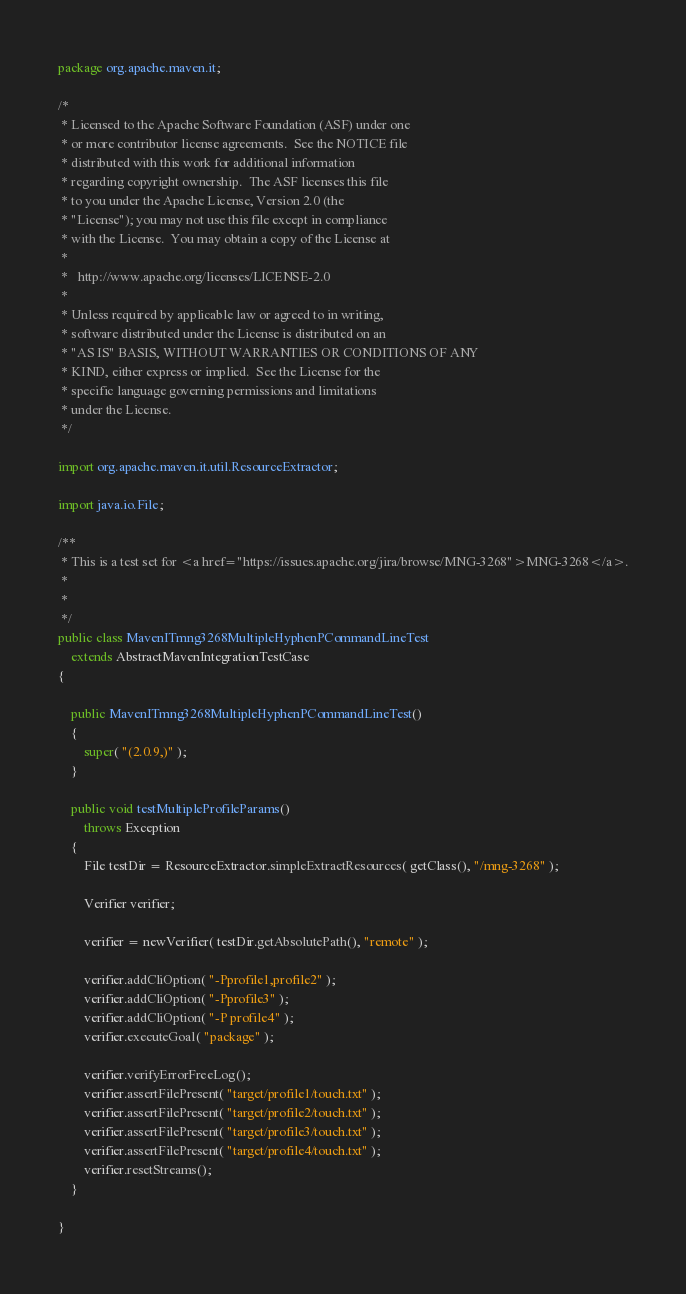<code> <loc_0><loc_0><loc_500><loc_500><_Java_>package org.apache.maven.it;

/*
 * Licensed to the Apache Software Foundation (ASF) under one
 * or more contributor license agreements.  See the NOTICE file
 * distributed with this work for additional information
 * regarding copyright ownership.  The ASF licenses this file
 * to you under the Apache License, Version 2.0 (the
 * "License"); you may not use this file except in compliance
 * with the License.  You may obtain a copy of the License at
 *
 *   http://www.apache.org/licenses/LICENSE-2.0
 *
 * Unless required by applicable law or agreed to in writing,
 * software distributed under the License is distributed on an
 * "AS IS" BASIS, WITHOUT WARRANTIES OR CONDITIONS OF ANY
 * KIND, either express or implied.  See the License for the
 * specific language governing permissions and limitations
 * under the License.
 */

import org.apache.maven.it.util.ResourceExtractor;

import java.io.File;

/**
 * This is a test set for <a href="https://issues.apache.org/jira/browse/MNG-3268">MNG-3268</a>.
 *
 *
 */
public class MavenITmng3268MultipleHyphenPCommandLineTest
    extends AbstractMavenIntegrationTestCase
{

    public MavenITmng3268MultipleHyphenPCommandLineTest()
    {
        super( "(2.0.9,)" );
    }

    public void testMultipleProfileParams()
        throws Exception
    {
        File testDir = ResourceExtractor.simpleExtractResources( getClass(), "/mng-3268" );

        Verifier verifier;

        verifier = newVerifier( testDir.getAbsolutePath(), "remote" );

        verifier.addCliOption( "-Pprofile1,profile2" );
        verifier.addCliOption( "-Pprofile3" );
        verifier.addCliOption( "-P profile4" );
        verifier.executeGoal( "package" );

        verifier.verifyErrorFreeLog();
        verifier.assertFilePresent( "target/profile1/touch.txt" );
        verifier.assertFilePresent( "target/profile2/touch.txt" );
        verifier.assertFilePresent( "target/profile3/touch.txt" );
        verifier.assertFilePresent( "target/profile4/touch.txt" );
        verifier.resetStreams();
    }

}
</code> 